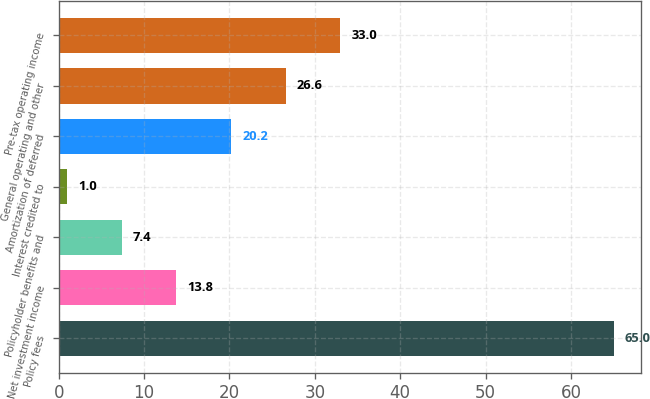<chart> <loc_0><loc_0><loc_500><loc_500><bar_chart><fcel>Policy fees<fcel>Net investment income<fcel>Policyholder benefits and<fcel>Interest credited to<fcel>Amortization of deferred<fcel>General operating and other<fcel>Pre-tax operating income<nl><fcel>65<fcel>13.8<fcel>7.4<fcel>1<fcel>20.2<fcel>26.6<fcel>33<nl></chart> 